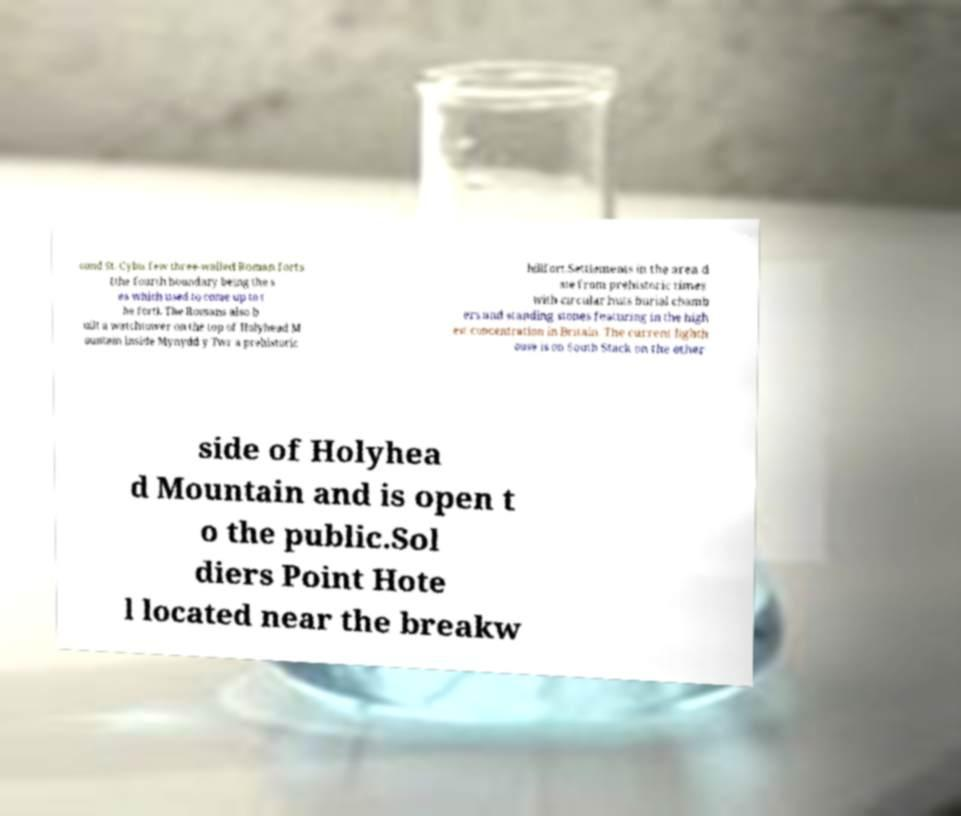What messages or text are displayed in this image? I need them in a readable, typed format. ound St. Cybis few three-walled Roman forts (the fourth boundary being the s ea which used to come up to t he fort). The Romans also b uilt a watchtower on the top of Holyhead M ountain inside Mynydd y Twr a prehistoric hillfort.Settlements in the area d ate from prehistoric times with circular huts burial chamb ers and standing stones featuring in the high est concentration in Britain. The current lighth ouse is on South Stack on the other side of Holyhea d Mountain and is open t o the public.Sol diers Point Hote l located near the breakw 